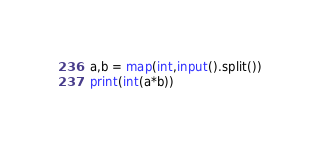<code> <loc_0><loc_0><loc_500><loc_500><_Python_>a,b = map(int,input().split())
print(int(a*b))</code> 